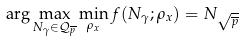Convert formula to latex. <formula><loc_0><loc_0><loc_500><loc_500>\arg \max _ { N _ { \gamma } \in \mathcal { Q } _ { \overline { p } } } \min _ { \rho _ { x } } f ( N _ { \gamma } ; \rho _ { x } ) = N _ { \sqrt { \overline { p } } }</formula> 